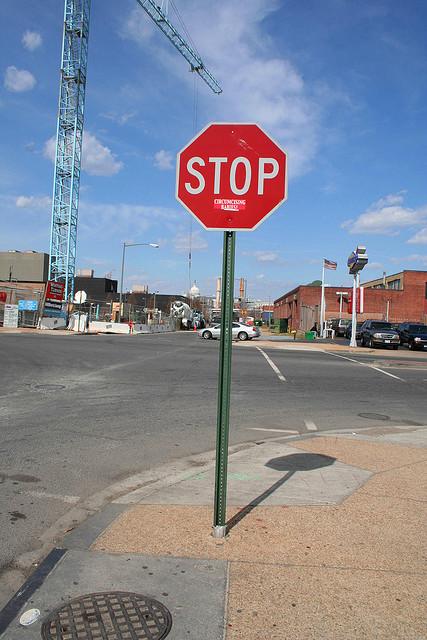What type of traffic signal is this?
Short answer required. Stop sign. What is casting a shadow?
Give a very brief answer. Stop sign. Is there a sticker on the stop sign?
Write a very short answer. Yes. 